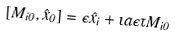<formula> <loc_0><loc_0><loc_500><loc_500>\ [ M _ { i 0 } , \hat { x } _ { 0 } ] = \epsilon \hat { x } _ { i } + \imath a \epsilon \tau M _ { i 0 }</formula> 